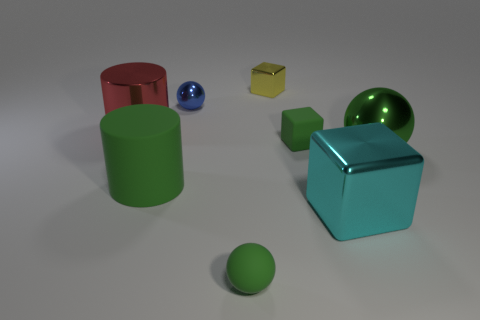Add 2 small green balls. How many objects exist? 10 Subtract all cubes. How many objects are left? 5 Subtract all yellow metallic things. Subtract all big cyan blocks. How many objects are left? 6 Add 4 cylinders. How many cylinders are left? 6 Add 6 small green blocks. How many small green blocks exist? 7 Subtract 0 gray cubes. How many objects are left? 8 